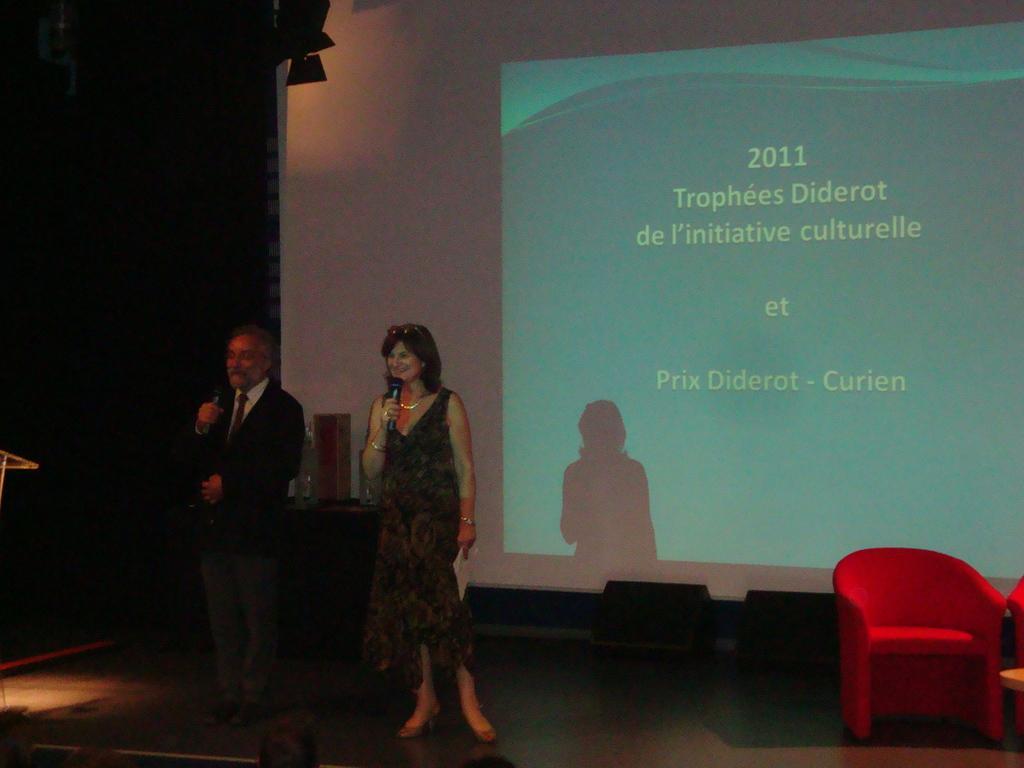Please provide a concise description of this image. In this picture we can see a chair and some objects on the right side. There are loudspeakers visible on the ground. We can see an object on the left side. There are a few objects, some text and numbers are visible on a projector screen. 